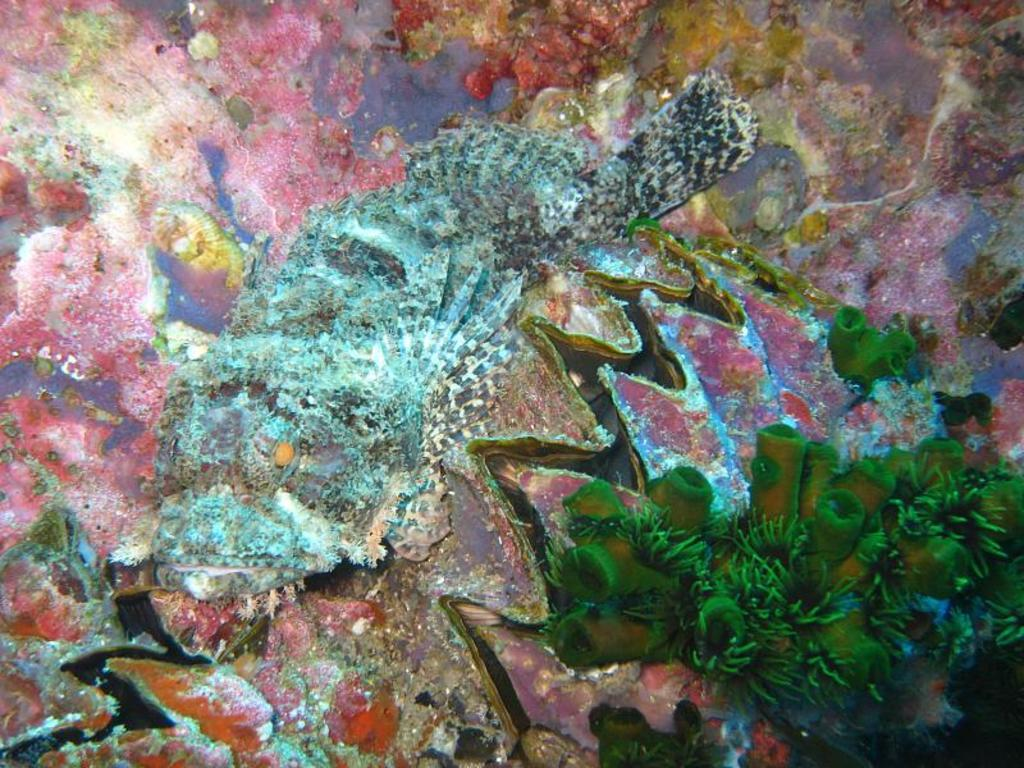What type of artwork is depicted in the image? The image appears to be a painting. What can be seen on the right side of the painting? There are plants on the right side of the image. Can you describe the sink in the painting? There is no sink present in the painting; it features plants on the right side. What type of conversation is happening between the plants in the painting? The plants in the painting are not engaged in a conversation, as they are inanimate objects. 